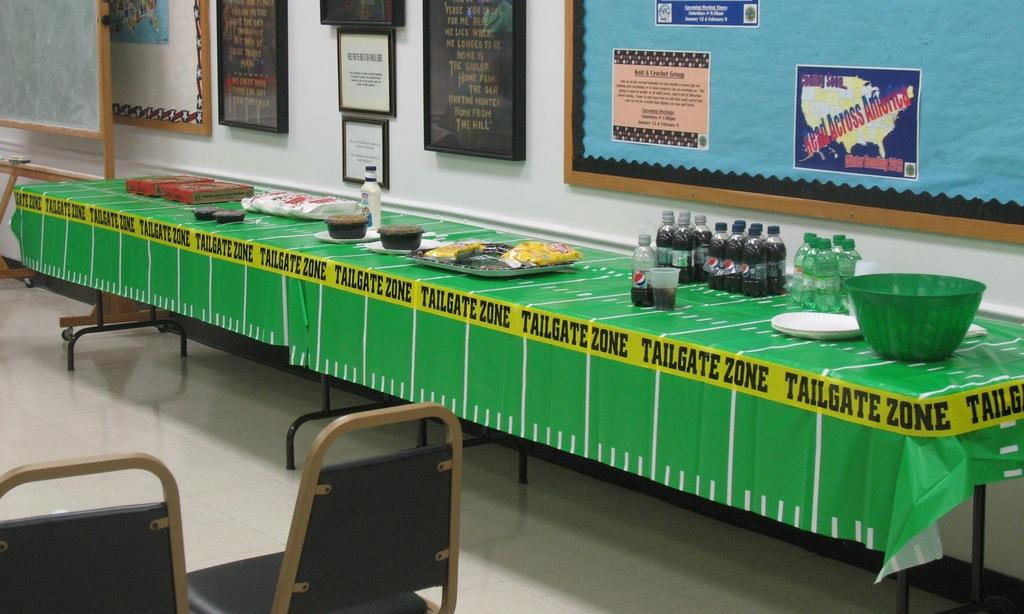What type of beverages can be seen on the table in the image? There are Pepsi and Sprite bottles on the table. Are there any other objects visible on the table? The provided facts do not mention any other objects on the table. What is located on the left side of the image? There are chairs on the left side of the image. Are there any pets visible in the image? There is no mention of pets in the provided facts, so we cannot determine if any are present in the image. 